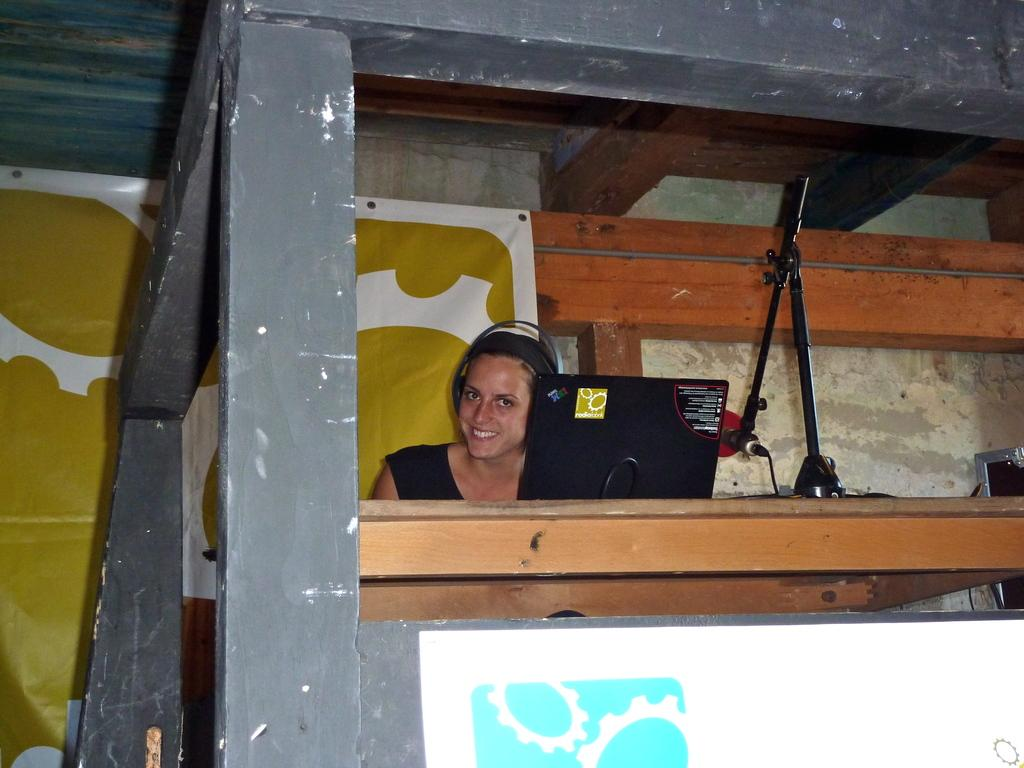Who is present in the image? There is a woman in the image. What is the woman wearing? The woman is wearing headsets. What is the woman's facial expression? The woman is smiling. What objects are on the table in the image? There is a laptop and a microphone on the table. What can be seen in the background of the image? There is a poster in the background. How does the woman's tongue contribute to the profit in the image? There is no mention of a tongue or profit in the image; it features a woman wearing headsets, smiling, and with a laptop, microphone, and poster in the background. 